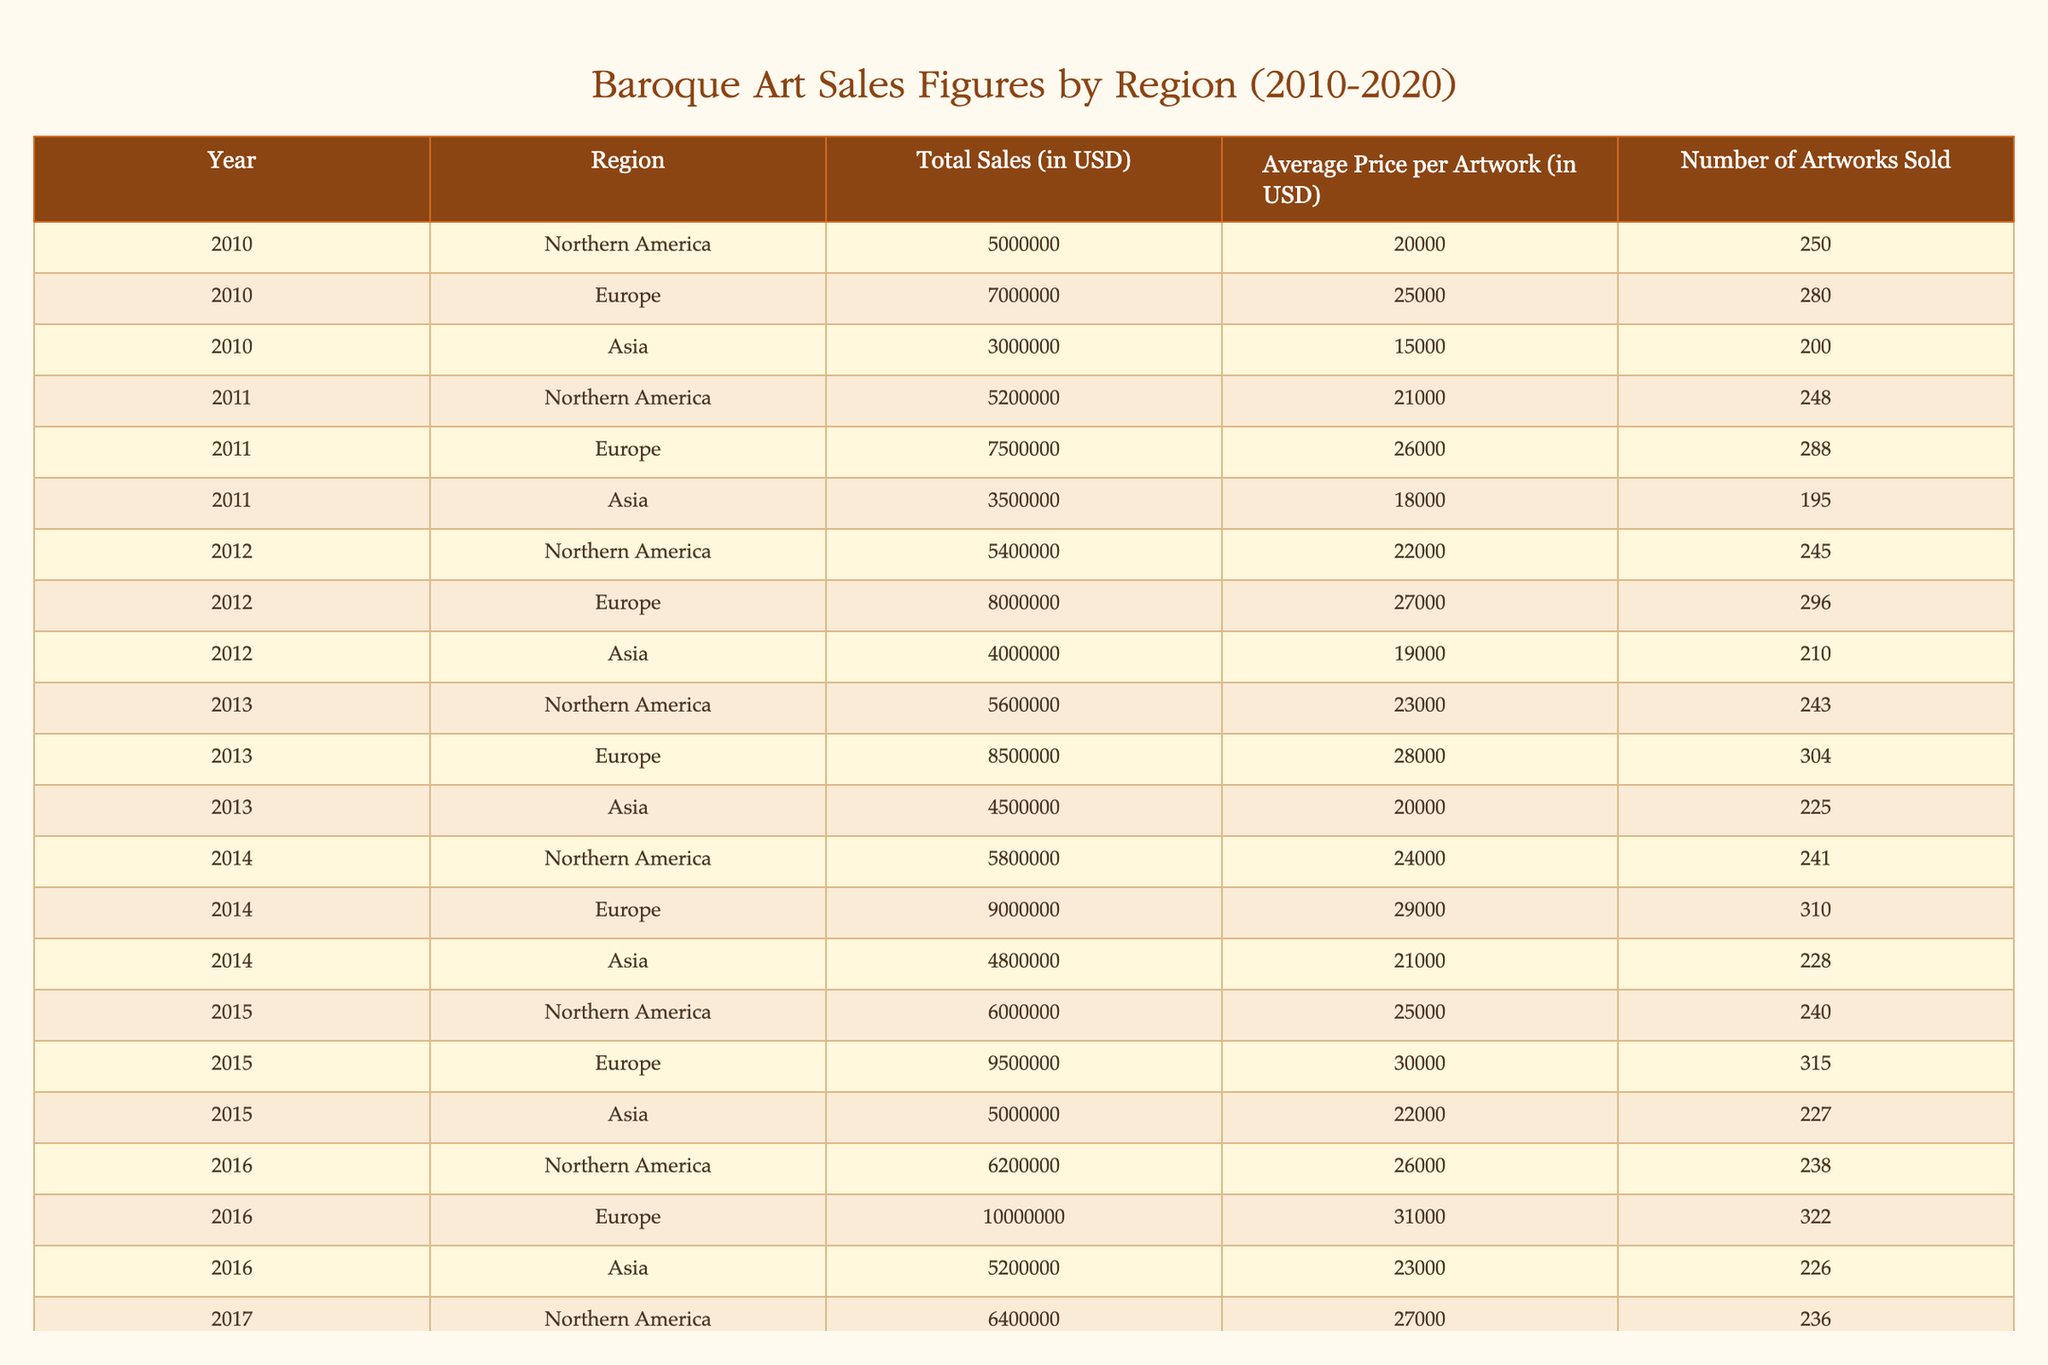What was the total sales figure for Europe in 2015? In the table, we look for the row corresponding to Europe and the year 2015. The total sales figure listed there is 9500000 USD.
Answer: 9500000 USD Which region had the highest average price per artwork in 2018? We compare the average price per artwork for all regions in 2018. Northern America had 28000 USD, Europe had 33000 USD, and Asia had 25000 USD. The highest is 33000 USD for Europe.
Answer: Europe What is the total sales for all regions in 2010? We sum the total sales for each region in 2010: Northern America (5000000) + Europe (7000000) + Asia (3000000) = 15000000 USD.
Answer: 15000000 USD Was there an increase in total sales for Asia from 2012 to 2013? The total sales for Asia in 2012 was 4000000 USD, and in 2013 it was 4500000 USD. Since 4500000 is greater than 4000000, there was an increase.
Answer: Yes What was the percentage increase in total sales for Northern America from 2010 to 2020? The total sales for Northern America in 2010 was 5000000 USD and in 2020 it was 7000000 USD. The increase is 7000000 - 5000000 = 2000000 USD. The percentage increase is (2000000 / 5000000) * 100 = 40%.
Answer: 40% In which year did Europe achieve total sales of over 10000000 USD for the first time? We look through the total sales figures for Europe across the years in the table. The first year that exceeds 10000000 USD is 2016 (10000000), and subsequent years also exceed this figure.
Answer: 2016 What was the average number of artworks sold in Asia from 2010 to 2020? We sum the number of artworks sold in Asia for each year from 2010 to 2020: (200 + 195 + 210 + 225 + 228 + 226 + 229 + 232 + 231 + 230) =  2274. Then, divide by the number of years (10), so 2274 / 10 = 227.4, rounding gives approximately 227.
Answer: 227 Did the average price per artwork in Europe increase every year from 2010 to 2020? Reviewing the average prices in Europe for each year shows the following: 25000, 26000, 27000, 28000, 29000, 30000, 31000, 32000, 33000, and 34000. Since all these prices are in increasing order, the answer is yes.
Answer: Yes What is the difference in total sales between Northern America and Europe in 2014? The total sales for Northern America in 2014 was 5800000 USD, and for Europe, it was 9000000 USD. The difference is 9000000 - 5800000 = 3200000 USD.
Answer: 3200000 USD 